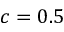Convert formula to latex. <formula><loc_0><loc_0><loc_500><loc_500>c = 0 . 5</formula> 